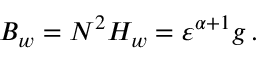Convert formula to latex. <formula><loc_0><loc_0><loc_500><loc_500>\begin{array} { r } { B _ { w } = N ^ { 2 } H _ { w } = { \varepsilon } ^ { \alpha + 1 } g \, . } \end{array}</formula> 